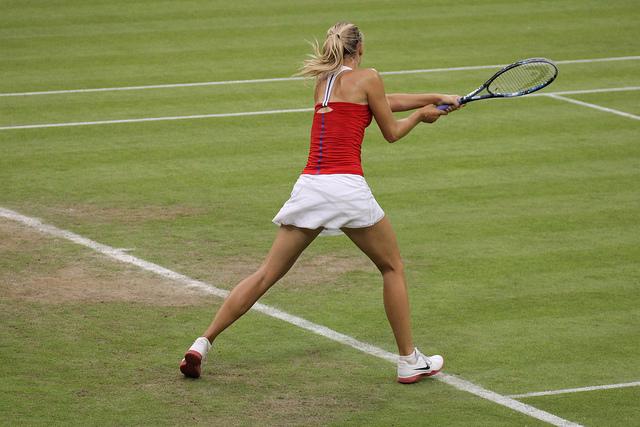Is she standing still?
Concise answer only. No. Is she wearing pantyhose?
Short answer required. No. Does this lady have a braid in her hair?
Short answer required. No. What color is her skirt?
Short answer required. White. What brand of tennis shoes is she wearing?
Give a very brief answer. Nike. 